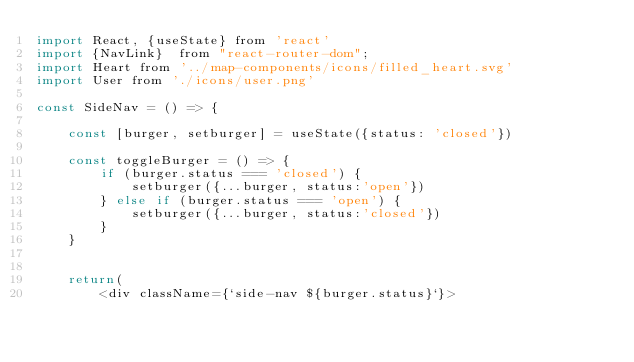<code> <loc_0><loc_0><loc_500><loc_500><_JavaScript_>import React, {useState} from 'react'
import {NavLink}  from "react-router-dom";
import Heart from '../map-components/icons/filled_heart.svg'
import User from './icons/user.png'

const SideNav = () => {

    const [burger, setburger] = useState({status: 'closed'})

    const toggleBurger = () => {
        if (burger.status === 'closed') {
            setburger({...burger, status:'open'}) 
        } else if (burger.status === 'open') {
            setburger({...burger, status:'closed'})
        }
    }


    return(
        <div className={`side-nav ${burger.status}`}></code> 